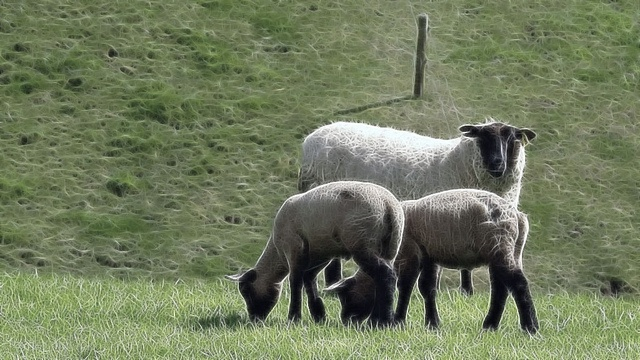Describe the objects in this image and their specific colors. I can see sheep in darkgreen, black, gray, darkgray, and lightgray tones, sheep in darkgreen, gray, lightgray, darkgray, and black tones, and sheep in darkgreen, black, gray, darkgray, and lightgray tones in this image. 